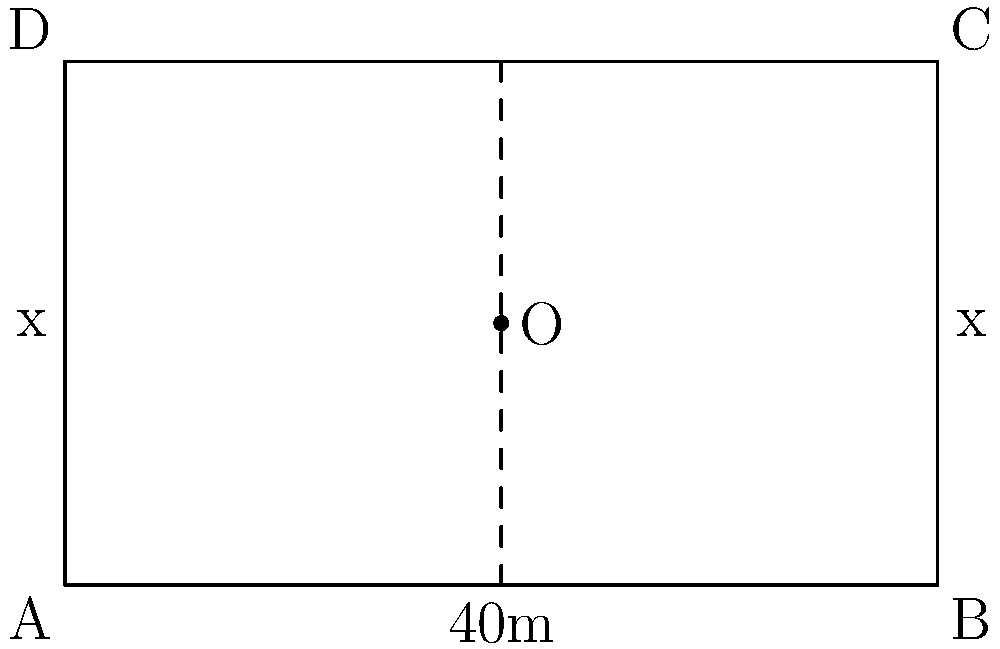A rural community wants to create a rectangular garden with a perimeter of 120 meters. If the width of the garden is represented by x, what should be the dimensions of the garden to maximize its area? How does this relate to efficiently using resources in rural education initiatives? Let's approach this step-by-step:

1) Given that the perimeter is 120 meters, we can set up an equation:
   $2l + 2w = 120$, where $l$ is length and $w$ is width.

2) We're told that the width is $x$, so let's express length in terms of $x$:
   $2l + 2x = 120$
   $l = 60 - x$

3) The area of a rectangle is given by $A = lw$. Substituting our expression for $l$:
   $A = (60 - x)x = 60x - x^2$

4) To find the maximum area, we need to find where the derivative of $A$ with respect to $x$ is zero:
   $\frac{dA}{dx} = 60 - 2x$
   Set this equal to zero: $60 - 2x = 0$
   Solve for $x$: $x = 30$

5) This means the width should be 30 meters. The length will also be 30 meters (60 - 30).

6) We can confirm this is a maximum by checking the second derivative:
   $\frac{d^2A}{dx^2} = -2$, which is negative, confirming a maximum.

7) The maximum area is therefore $30 * 30 = 900$ square meters.

This relates to rural education initiatives by demonstrating the importance of optimizing resource use. Just as we've maximized garden area with limited fencing, education officers must maximize educational impact with limited resources. This could involve optimizing classroom sizes, efficiently allocating teaching materials, or balancing the distribution of teachers across schools to reach the most students effectively.
Answer: 30m x 30m rectangle; Area = 900 sq m 